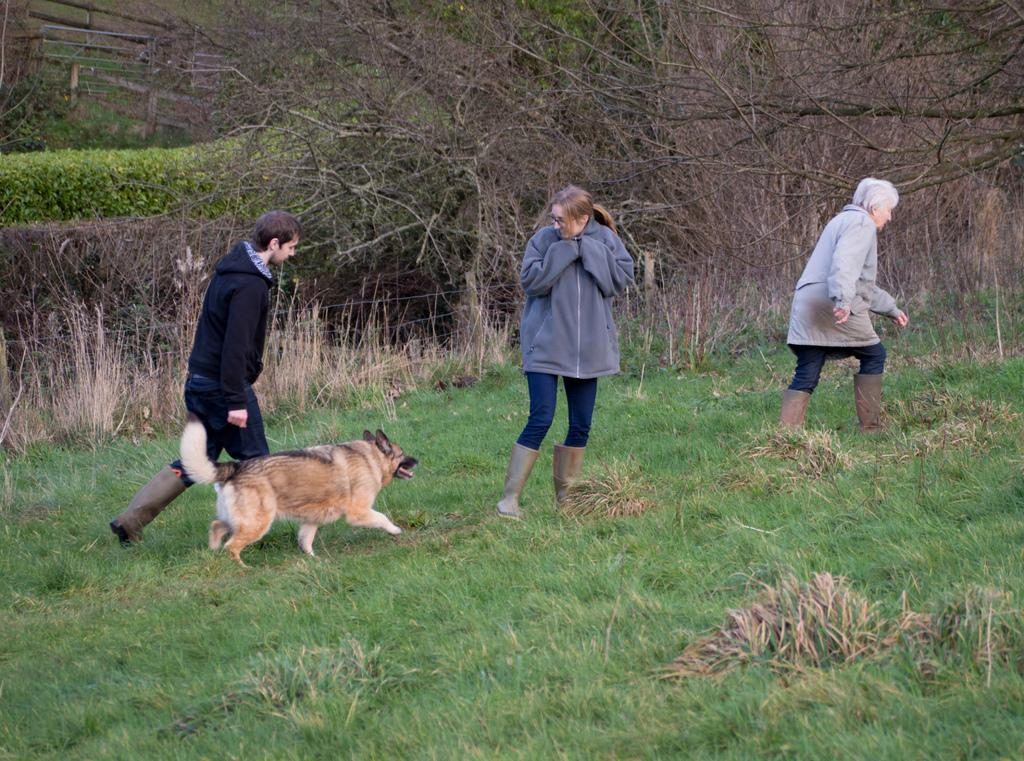How many people are in the image? There are three persons in the image. What other living creature is present in the image? There is a dog in the image. What type of vegetation is at the bottom of the image? Grass is present at the bottom of the image. What can be seen in the background of the image? There are trees in the background of the image. What is located in the middle of the image? There is fencing in the middle of the image. What type of pies are being served to the dog in the image? There are no pies present in the image, and the dog is not being served anything. 